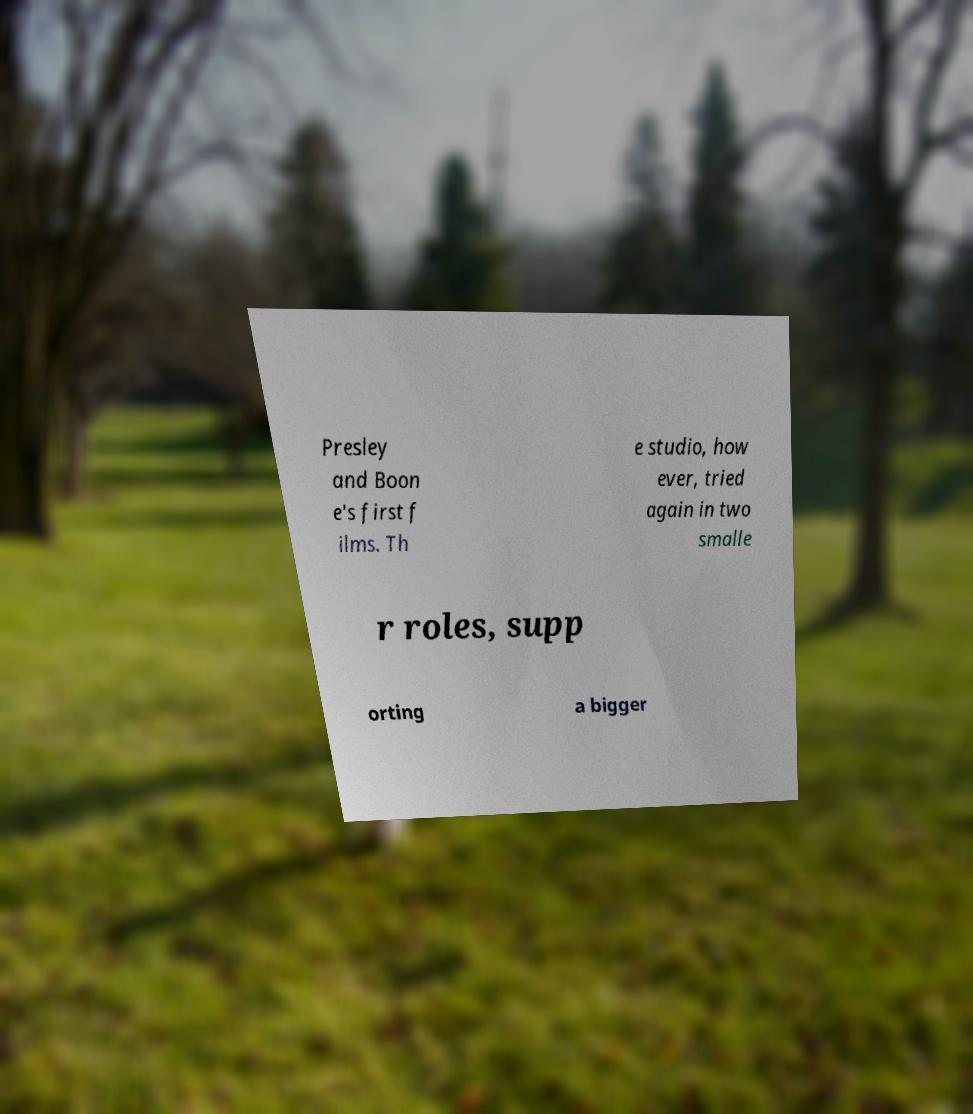Please identify and transcribe the text found in this image. Presley and Boon e's first f ilms. Th e studio, how ever, tried again in two smalle r roles, supp orting a bigger 